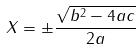<formula> <loc_0><loc_0><loc_500><loc_500>X = \pm \frac { \sqrt { b ^ { 2 } - 4 a c } } { 2 a }</formula> 